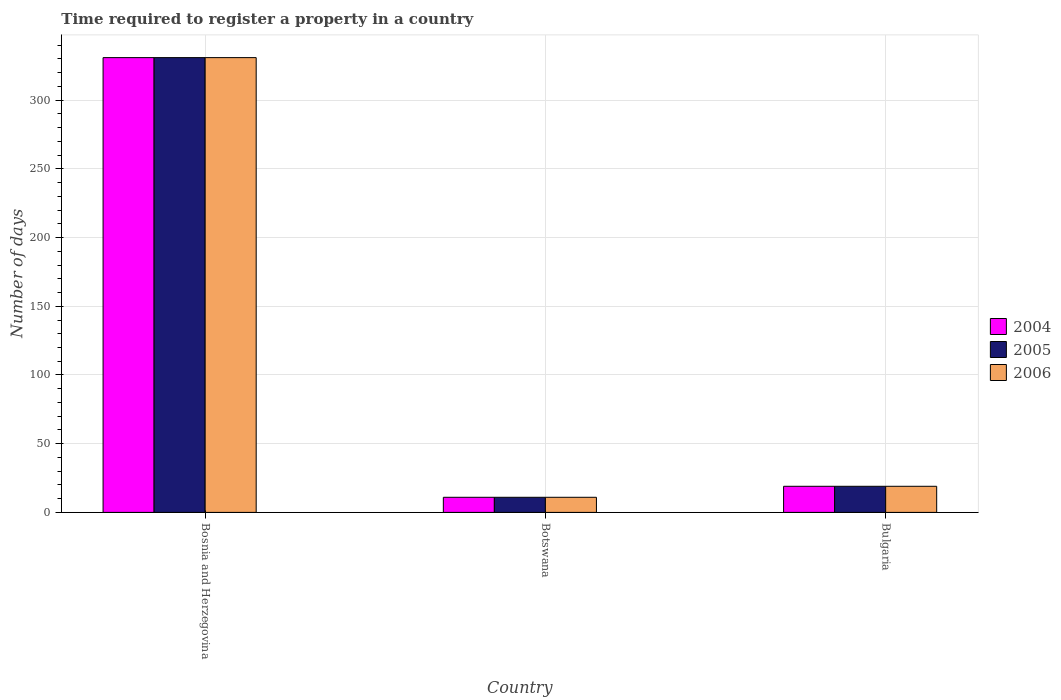How many different coloured bars are there?
Offer a terse response. 3. Are the number of bars per tick equal to the number of legend labels?
Offer a very short reply. Yes. How many bars are there on the 2nd tick from the left?
Keep it short and to the point. 3. What is the label of the 2nd group of bars from the left?
Your answer should be very brief. Botswana. Across all countries, what is the maximum number of days required to register a property in 2005?
Ensure brevity in your answer.  331. Across all countries, what is the minimum number of days required to register a property in 2005?
Provide a succinct answer. 11. In which country was the number of days required to register a property in 2006 maximum?
Your answer should be compact. Bosnia and Herzegovina. In which country was the number of days required to register a property in 2006 minimum?
Keep it short and to the point. Botswana. What is the total number of days required to register a property in 2006 in the graph?
Offer a very short reply. 361. What is the difference between the number of days required to register a property in 2005 in Bosnia and Herzegovina and that in Botswana?
Provide a succinct answer. 320. What is the average number of days required to register a property in 2004 per country?
Keep it short and to the point. 120.33. What is the difference between the number of days required to register a property of/in 2005 and number of days required to register a property of/in 2004 in Bulgaria?
Offer a very short reply. 0. What is the ratio of the number of days required to register a property in 2006 in Bosnia and Herzegovina to that in Bulgaria?
Offer a very short reply. 17.42. Is the number of days required to register a property in 2004 in Bosnia and Herzegovina less than that in Botswana?
Give a very brief answer. No. What is the difference between the highest and the second highest number of days required to register a property in 2005?
Your response must be concise. 8. What is the difference between the highest and the lowest number of days required to register a property in 2004?
Make the answer very short. 320. Is the sum of the number of days required to register a property in 2005 in Bosnia and Herzegovina and Bulgaria greater than the maximum number of days required to register a property in 2004 across all countries?
Provide a succinct answer. Yes. What does the 1st bar from the right in Bulgaria represents?
Keep it short and to the point. 2006. How many bars are there?
Your answer should be compact. 9. Are the values on the major ticks of Y-axis written in scientific E-notation?
Keep it short and to the point. No. Does the graph contain grids?
Make the answer very short. Yes. Where does the legend appear in the graph?
Your answer should be very brief. Center right. How many legend labels are there?
Keep it short and to the point. 3. How are the legend labels stacked?
Offer a very short reply. Vertical. What is the title of the graph?
Make the answer very short. Time required to register a property in a country. Does "1995" appear as one of the legend labels in the graph?
Offer a very short reply. No. What is the label or title of the X-axis?
Provide a succinct answer. Country. What is the label or title of the Y-axis?
Your response must be concise. Number of days. What is the Number of days of 2004 in Bosnia and Herzegovina?
Make the answer very short. 331. What is the Number of days of 2005 in Bosnia and Herzegovina?
Provide a short and direct response. 331. What is the Number of days of 2006 in Bosnia and Herzegovina?
Ensure brevity in your answer.  331. What is the Number of days in 2004 in Botswana?
Keep it short and to the point. 11. What is the Number of days of 2004 in Bulgaria?
Make the answer very short. 19. What is the Number of days of 2006 in Bulgaria?
Your answer should be compact. 19. Across all countries, what is the maximum Number of days of 2004?
Ensure brevity in your answer.  331. Across all countries, what is the maximum Number of days in 2005?
Your answer should be compact. 331. Across all countries, what is the maximum Number of days in 2006?
Make the answer very short. 331. Across all countries, what is the minimum Number of days of 2004?
Offer a terse response. 11. What is the total Number of days of 2004 in the graph?
Your response must be concise. 361. What is the total Number of days of 2005 in the graph?
Give a very brief answer. 361. What is the total Number of days in 2006 in the graph?
Provide a short and direct response. 361. What is the difference between the Number of days of 2004 in Bosnia and Herzegovina and that in Botswana?
Your answer should be very brief. 320. What is the difference between the Number of days in 2005 in Bosnia and Herzegovina and that in Botswana?
Make the answer very short. 320. What is the difference between the Number of days of 2006 in Bosnia and Herzegovina and that in Botswana?
Your answer should be compact. 320. What is the difference between the Number of days in 2004 in Bosnia and Herzegovina and that in Bulgaria?
Your response must be concise. 312. What is the difference between the Number of days of 2005 in Bosnia and Herzegovina and that in Bulgaria?
Offer a very short reply. 312. What is the difference between the Number of days of 2006 in Bosnia and Herzegovina and that in Bulgaria?
Your response must be concise. 312. What is the difference between the Number of days of 2004 in Botswana and that in Bulgaria?
Offer a terse response. -8. What is the difference between the Number of days in 2004 in Bosnia and Herzegovina and the Number of days in 2005 in Botswana?
Your response must be concise. 320. What is the difference between the Number of days in 2004 in Bosnia and Herzegovina and the Number of days in 2006 in Botswana?
Keep it short and to the point. 320. What is the difference between the Number of days of 2005 in Bosnia and Herzegovina and the Number of days of 2006 in Botswana?
Make the answer very short. 320. What is the difference between the Number of days in 2004 in Bosnia and Herzegovina and the Number of days in 2005 in Bulgaria?
Provide a short and direct response. 312. What is the difference between the Number of days of 2004 in Bosnia and Herzegovina and the Number of days of 2006 in Bulgaria?
Keep it short and to the point. 312. What is the difference between the Number of days in 2005 in Bosnia and Herzegovina and the Number of days in 2006 in Bulgaria?
Give a very brief answer. 312. What is the average Number of days in 2004 per country?
Keep it short and to the point. 120.33. What is the average Number of days of 2005 per country?
Keep it short and to the point. 120.33. What is the average Number of days in 2006 per country?
Make the answer very short. 120.33. What is the difference between the Number of days of 2004 and Number of days of 2005 in Bosnia and Herzegovina?
Keep it short and to the point. 0. What is the difference between the Number of days of 2004 and Number of days of 2006 in Bosnia and Herzegovina?
Your answer should be very brief. 0. What is the ratio of the Number of days in 2004 in Bosnia and Herzegovina to that in Botswana?
Offer a very short reply. 30.09. What is the ratio of the Number of days of 2005 in Bosnia and Herzegovina to that in Botswana?
Your answer should be very brief. 30.09. What is the ratio of the Number of days in 2006 in Bosnia and Herzegovina to that in Botswana?
Offer a terse response. 30.09. What is the ratio of the Number of days of 2004 in Bosnia and Herzegovina to that in Bulgaria?
Offer a very short reply. 17.42. What is the ratio of the Number of days in 2005 in Bosnia and Herzegovina to that in Bulgaria?
Provide a succinct answer. 17.42. What is the ratio of the Number of days in 2006 in Bosnia and Herzegovina to that in Bulgaria?
Make the answer very short. 17.42. What is the ratio of the Number of days of 2004 in Botswana to that in Bulgaria?
Offer a very short reply. 0.58. What is the ratio of the Number of days in 2005 in Botswana to that in Bulgaria?
Your answer should be compact. 0.58. What is the ratio of the Number of days of 2006 in Botswana to that in Bulgaria?
Provide a short and direct response. 0.58. What is the difference between the highest and the second highest Number of days of 2004?
Ensure brevity in your answer.  312. What is the difference between the highest and the second highest Number of days in 2005?
Your answer should be very brief. 312. What is the difference between the highest and the second highest Number of days of 2006?
Give a very brief answer. 312. What is the difference between the highest and the lowest Number of days of 2004?
Provide a short and direct response. 320. What is the difference between the highest and the lowest Number of days of 2005?
Ensure brevity in your answer.  320. What is the difference between the highest and the lowest Number of days of 2006?
Make the answer very short. 320. 